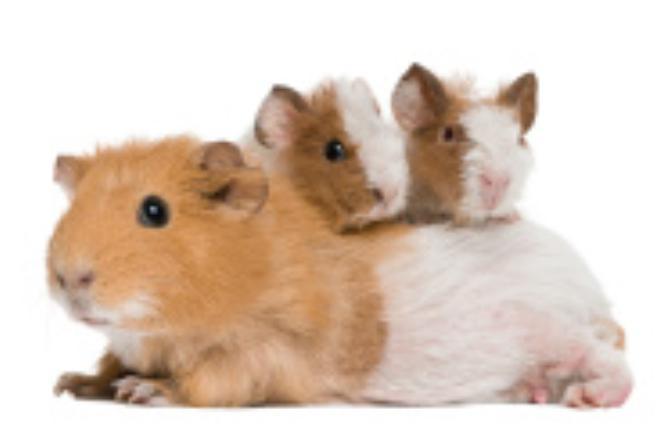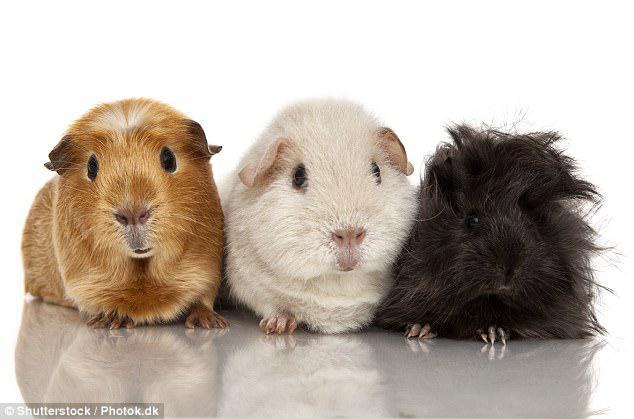The first image is the image on the left, the second image is the image on the right. Given the left and right images, does the statement "Two rodents are posing side by side." hold true? Answer yes or no. No. 